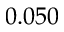<formula> <loc_0><loc_0><loc_500><loc_500>0 . 0 5 0</formula> 